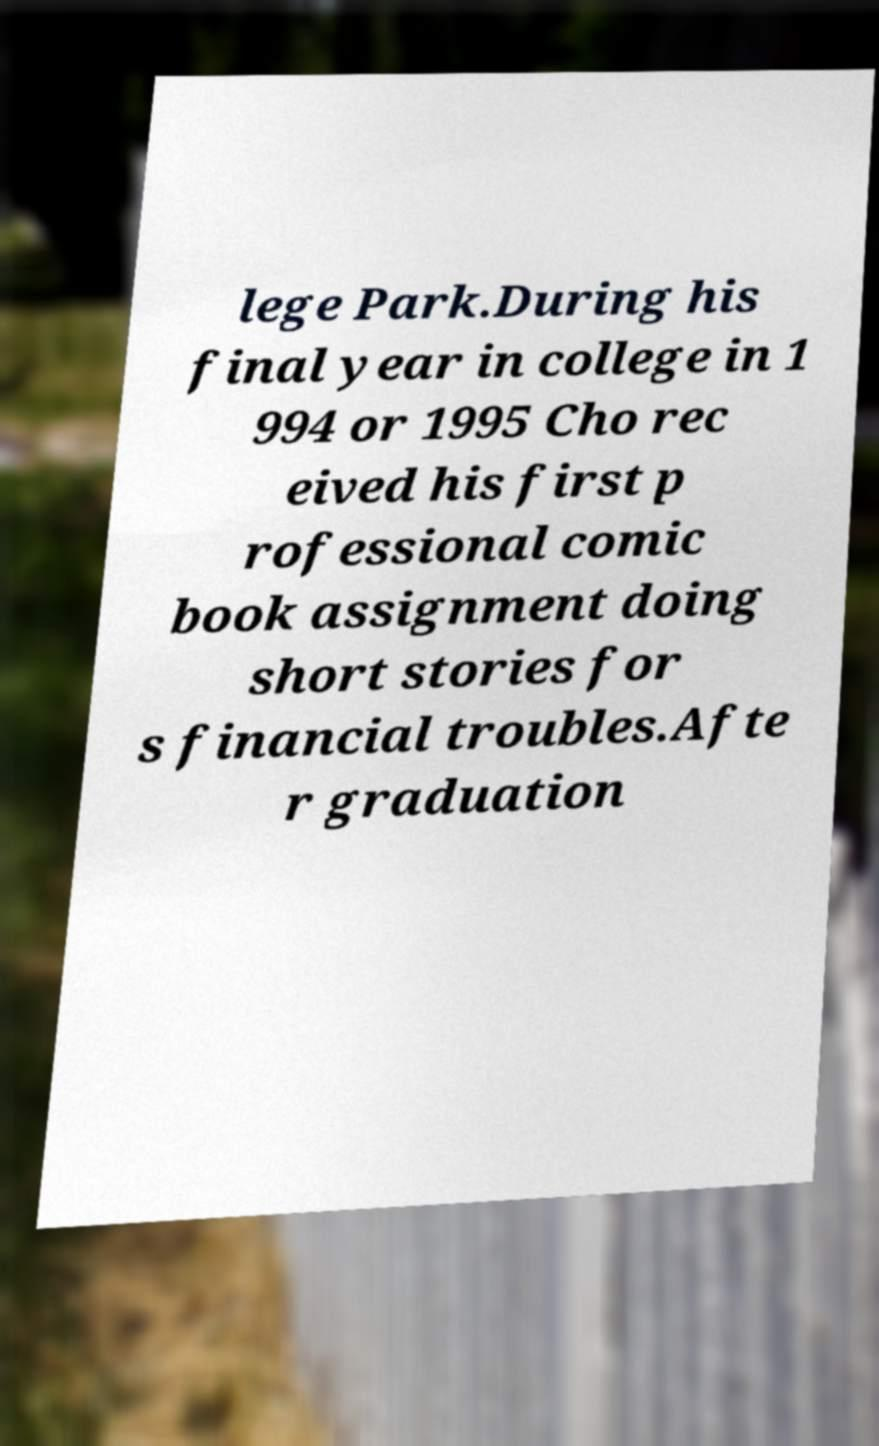Can you read and provide the text displayed in the image?This photo seems to have some interesting text. Can you extract and type it out for me? lege Park.During his final year in college in 1 994 or 1995 Cho rec eived his first p rofessional comic book assignment doing short stories for s financial troubles.Afte r graduation 